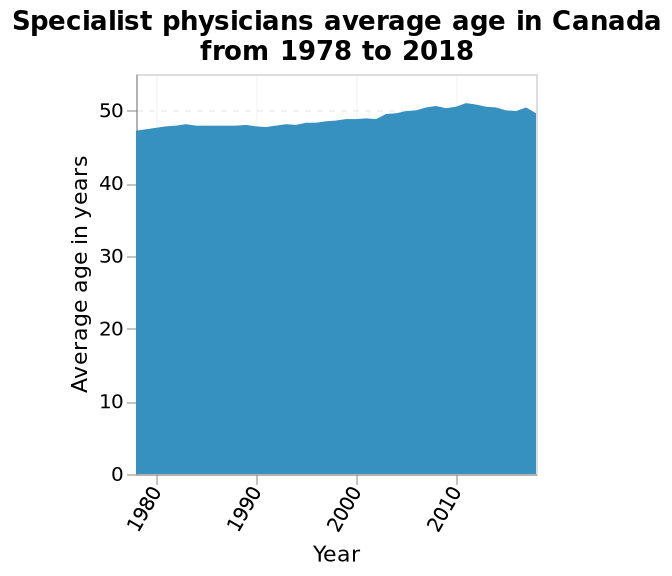<image>
What was the average age of physicians in Canada in 1978?  In 1978, the average age of physicians in Canada was in the late 40s. What is the range of the y-axis in the area plot? The range of the y-axis in the area plot is from 0 to 50. What was the average age of physicians in Canada in 2018?  In 2018, the average age of physicians in Canada was just over 50. 